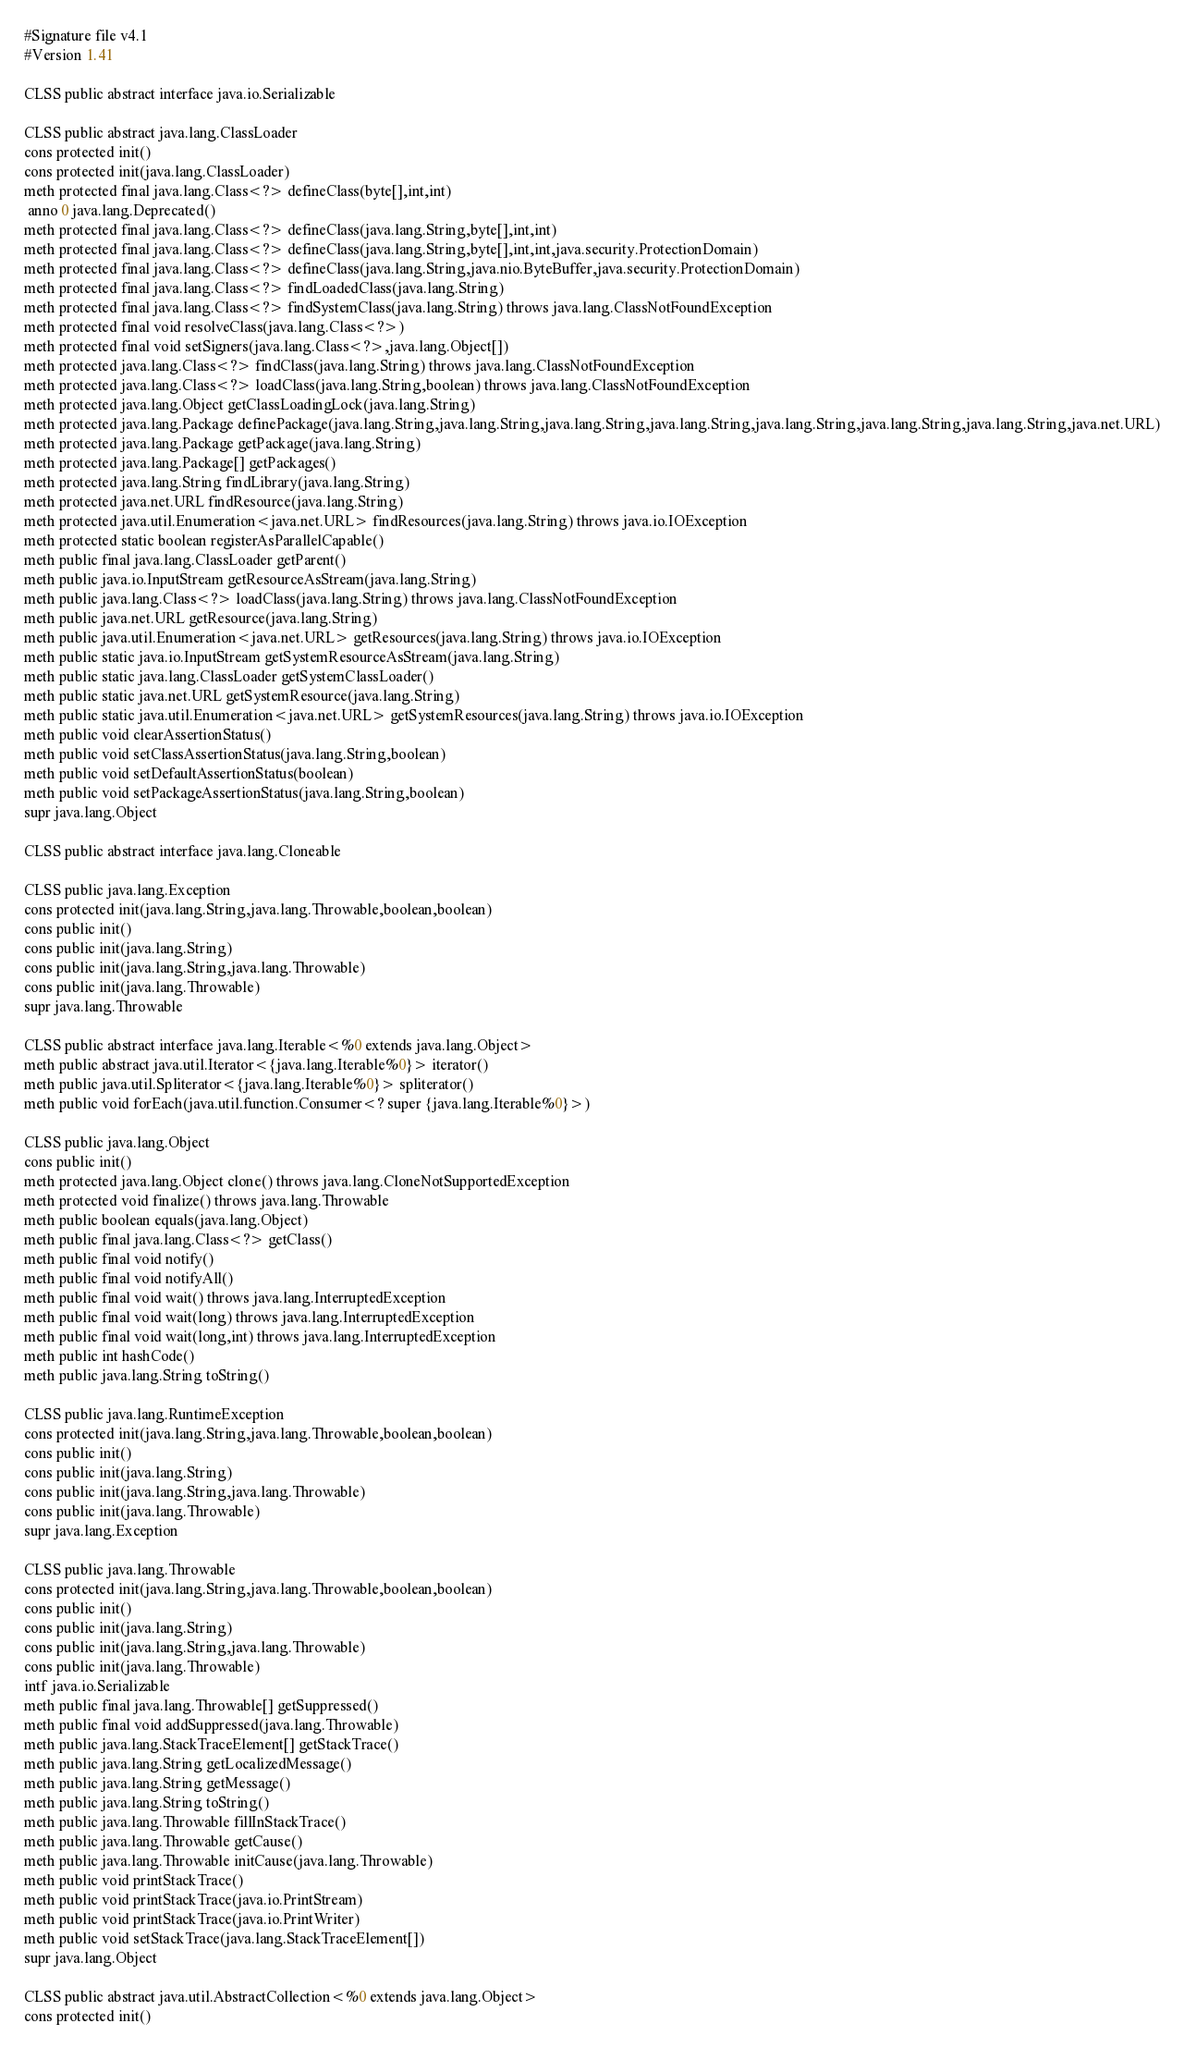Convert code to text. <code><loc_0><loc_0><loc_500><loc_500><_SML_>#Signature file v4.1
#Version 1.41

CLSS public abstract interface java.io.Serializable

CLSS public abstract java.lang.ClassLoader
cons protected init()
cons protected init(java.lang.ClassLoader)
meth protected final java.lang.Class<?> defineClass(byte[],int,int)
 anno 0 java.lang.Deprecated()
meth protected final java.lang.Class<?> defineClass(java.lang.String,byte[],int,int)
meth protected final java.lang.Class<?> defineClass(java.lang.String,byte[],int,int,java.security.ProtectionDomain)
meth protected final java.lang.Class<?> defineClass(java.lang.String,java.nio.ByteBuffer,java.security.ProtectionDomain)
meth protected final java.lang.Class<?> findLoadedClass(java.lang.String)
meth protected final java.lang.Class<?> findSystemClass(java.lang.String) throws java.lang.ClassNotFoundException
meth protected final void resolveClass(java.lang.Class<?>)
meth protected final void setSigners(java.lang.Class<?>,java.lang.Object[])
meth protected java.lang.Class<?> findClass(java.lang.String) throws java.lang.ClassNotFoundException
meth protected java.lang.Class<?> loadClass(java.lang.String,boolean) throws java.lang.ClassNotFoundException
meth protected java.lang.Object getClassLoadingLock(java.lang.String)
meth protected java.lang.Package definePackage(java.lang.String,java.lang.String,java.lang.String,java.lang.String,java.lang.String,java.lang.String,java.lang.String,java.net.URL)
meth protected java.lang.Package getPackage(java.lang.String)
meth protected java.lang.Package[] getPackages()
meth protected java.lang.String findLibrary(java.lang.String)
meth protected java.net.URL findResource(java.lang.String)
meth protected java.util.Enumeration<java.net.URL> findResources(java.lang.String) throws java.io.IOException
meth protected static boolean registerAsParallelCapable()
meth public final java.lang.ClassLoader getParent()
meth public java.io.InputStream getResourceAsStream(java.lang.String)
meth public java.lang.Class<?> loadClass(java.lang.String) throws java.lang.ClassNotFoundException
meth public java.net.URL getResource(java.lang.String)
meth public java.util.Enumeration<java.net.URL> getResources(java.lang.String) throws java.io.IOException
meth public static java.io.InputStream getSystemResourceAsStream(java.lang.String)
meth public static java.lang.ClassLoader getSystemClassLoader()
meth public static java.net.URL getSystemResource(java.lang.String)
meth public static java.util.Enumeration<java.net.URL> getSystemResources(java.lang.String) throws java.io.IOException
meth public void clearAssertionStatus()
meth public void setClassAssertionStatus(java.lang.String,boolean)
meth public void setDefaultAssertionStatus(boolean)
meth public void setPackageAssertionStatus(java.lang.String,boolean)
supr java.lang.Object

CLSS public abstract interface java.lang.Cloneable

CLSS public java.lang.Exception
cons protected init(java.lang.String,java.lang.Throwable,boolean,boolean)
cons public init()
cons public init(java.lang.String)
cons public init(java.lang.String,java.lang.Throwable)
cons public init(java.lang.Throwable)
supr java.lang.Throwable

CLSS public abstract interface java.lang.Iterable<%0 extends java.lang.Object>
meth public abstract java.util.Iterator<{java.lang.Iterable%0}> iterator()
meth public java.util.Spliterator<{java.lang.Iterable%0}> spliterator()
meth public void forEach(java.util.function.Consumer<? super {java.lang.Iterable%0}>)

CLSS public java.lang.Object
cons public init()
meth protected java.lang.Object clone() throws java.lang.CloneNotSupportedException
meth protected void finalize() throws java.lang.Throwable
meth public boolean equals(java.lang.Object)
meth public final java.lang.Class<?> getClass()
meth public final void notify()
meth public final void notifyAll()
meth public final void wait() throws java.lang.InterruptedException
meth public final void wait(long) throws java.lang.InterruptedException
meth public final void wait(long,int) throws java.lang.InterruptedException
meth public int hashCode()
meth public java.lang.String toString()

CLSS public java.lang.RuntimeException
cons protected init(java.lang.String,java.lang.Throwable,boolean,boolean)
cons public init()
cons public init(java.lang.String)
cons public init(java.lang.String,java.lang.Throwable)
cons public init(java.lang.Throwable)
supr java.lang.Exception

CLSS public java.lang.Throwable
cons protected init(java.lang.String,java.lang.Throwable,boolean,boolean)
cons public init()
cons public init(java.lang.String)
cons public init(java.lang.String,java.lang.Throwable)
cons public init(java.lang.Throwable)
intf java.io.Serializable
meth public final java.lang.Throwable[] getSuppressed()
meth public final void addSuppressed(java.lang.Throwable)
meth public java.lang.StackTraceElement[] getStackTrace()
meth public java.lang.String getLocalizedMessage()
meth public java.lang.String getMessage()
meth public java.lang.String toString()
meth public java.lang.Throwable fillInStackTrace()
meth public java.lang.Throwable getCause()
meth public java.lang.Throwable initCause(java.lang.Throwable)
meth public void printStackTrace()
meth public void printStackTrace(java.io.PrintStream)
meth public void printStackTrace(java.io.PrintWriter)
meth public void setStackTrace(java.lang.StackTraceElement[])
supr java.lang.Object

CLSS public abstract java.util.AbstractCollection<%0 extends java.lang.Object>
cons protected init()</code> 